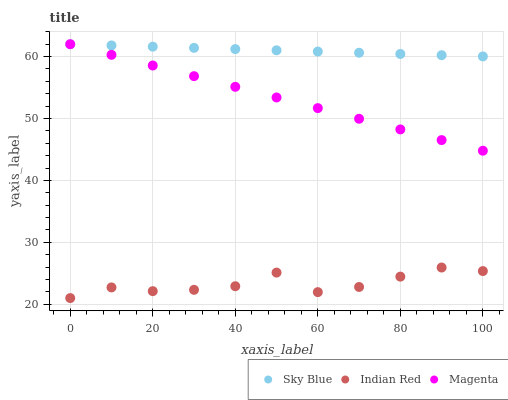Does Indian Red have the minimum area under the curve?
Answer yes or no. Yes. Does Sky Blue have the maximum area under the curve?
Answer yes or no. Yes. Does Magenta have the minimum area under the curve?
Answer yes or no. No. Does Magenta have the maximum area under the curve?
Answer yes or no. No. Is Magenta the smoothest?
Answer yes or no. Yes. Is Indian Red the roughest?
Answer yes or no. Yes. Is Indian Red the smoothest?
Answer yes or no. No. Is Magenta the roughest?
Answer yes or no. No. Does Indian Red have the lowest value?
Answer yes or no. Yes. Does Magenta have the lowest value?
Answer yes or no. No. Does Magenta have the highest value?
Answer yes or no. Yes. Does Indian Red have the highest value?
Answer yes or no. No. Is Indian Red less than Sky Blue?
Answer yes or no. Yes. Is Sky Blue greater than Indian Red?
Answer yes or no. Yes. Does Magenta intersect Sky Blue?
Answer yes or no. Yes. Is Magenta less than Sky Blue?
Answer yes or no. No. Is Magenta greater than Sky Blue?
Answer yes or no. No. Does Indian Red intersect Sky Blue?
Answer yes or no. No. 